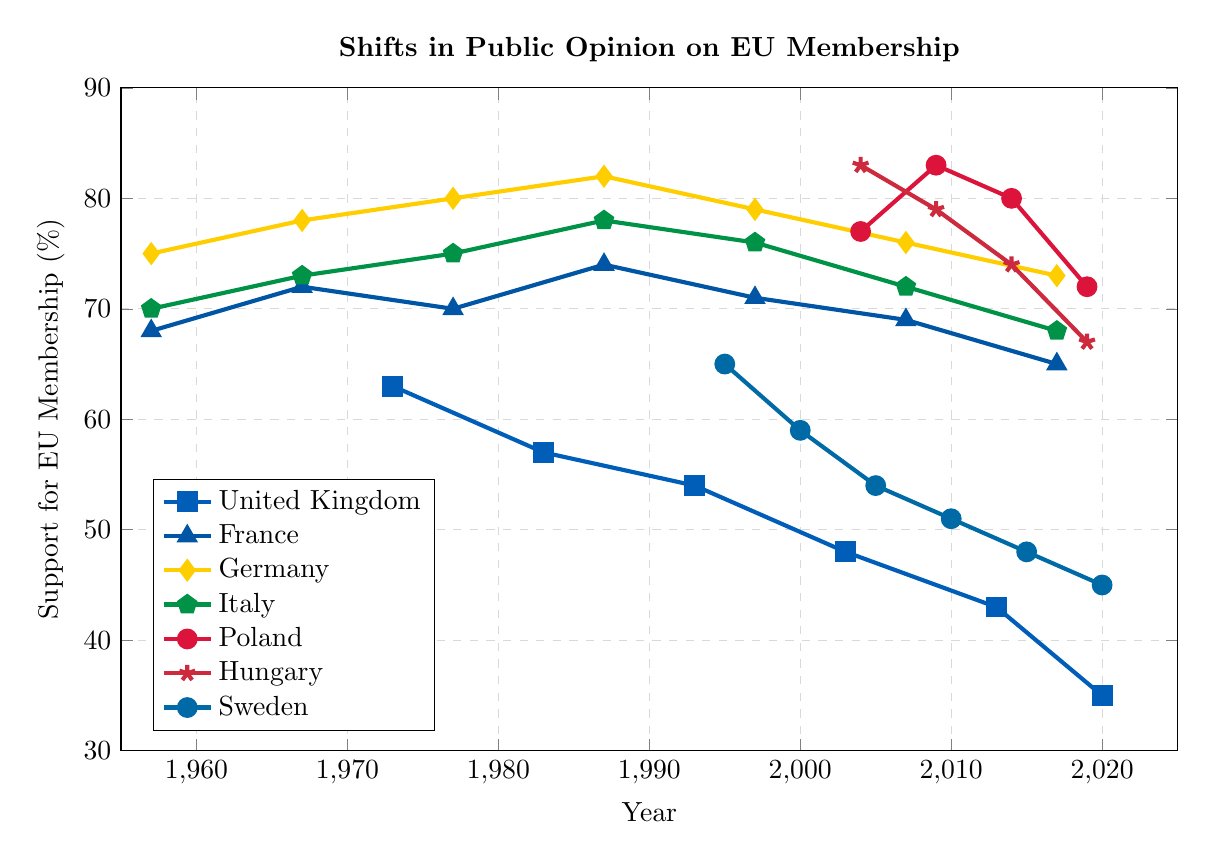When did the United Kingdom's support for EU membership start to drop below 50%? Identify the UK line and note the decrease from 2003. In 2003, support was 48%.
Answer: 2003 Which country had the highest percentage support for EU membership in 2004? Compare the support percentages for Poland and Hungary since other countries are not present in 2004. Hungary had 83%, higher than Poland's 77%.
Answer: Hungary How does Germany's support in 1957 compare to France's support in the same year? Identify Germany and France values in 1957. Germany: 75%, France: 68%. Germany's support was higher.
Answer: Germany's support was higher What is the general trend of Sweden's support for EU membership from 1995 to 2020? Follow Sweden's line noting a consistent decline from 65% in 1995 to 45% in 2020.
Answer: Consistent decline In which year did Italy have the highest support for EU membership? Scan Italy's values noting the peak is 78% which occurred in 1987.
Answer: 1987 What was the difference in support between France and the United Kingdom in 2013? Identify France and UK's values in 2013. France: not listed, but UK's value is 43%. Considering adjacent values, estimate France's as around 69 in 2007 or 65 in 2017 to indicate a consistent higher trend than UK's 43%.
Answer: Approximately 26% (assuming France's value proximate to surrounding years) What is the average support for EU membership in Poland over the years listed? Sum Poland's values (77 + 83 + 80 + 72) = 312, then divide by 4 (number of years). 312 / 4 = 78%.
Answer: 78% Which country showed a sharper decline in support between 2014 and 2019, Poland or Hungary? Compare Poland's drop from 80% to 72% (8%) and Hungary's drop from 74% to 67% (7%). Poland showed a sharper decline.
Answer: Poland Which country had the lowest support for EU membership in 2020? Compare all 2020 values. The UK had the lowest at 35%.
Answer: United Kingdom Between 1987 and 1997, which country displayed a decrease in support, and what was the approximate magnitude of the decrease? Scan France, Germany, and Italy values between 1987 and 1997. France decreased from 74% to 71% (3%); Germany and Italy remained relatively stable.
Answer: France, 3% decrease 